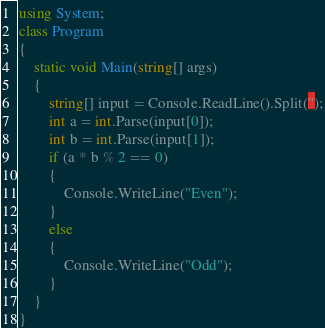<code> <loc_0><loc_0><loc_500><loc_500><_C#_>using System;
class Program 
{
    static void Main(string[] args)
    {
        string[] input = Console.ReadLine().Split('');
        int a = int.Parse(input[0]);
        int b = int.Parse(input[1]);
        if (a * b % 2 == 0)
        {
            Console.WriteLine("Even");
        }
        else
        {
            Console.WriteLine("Odd");
        }
    }
}
</code> 